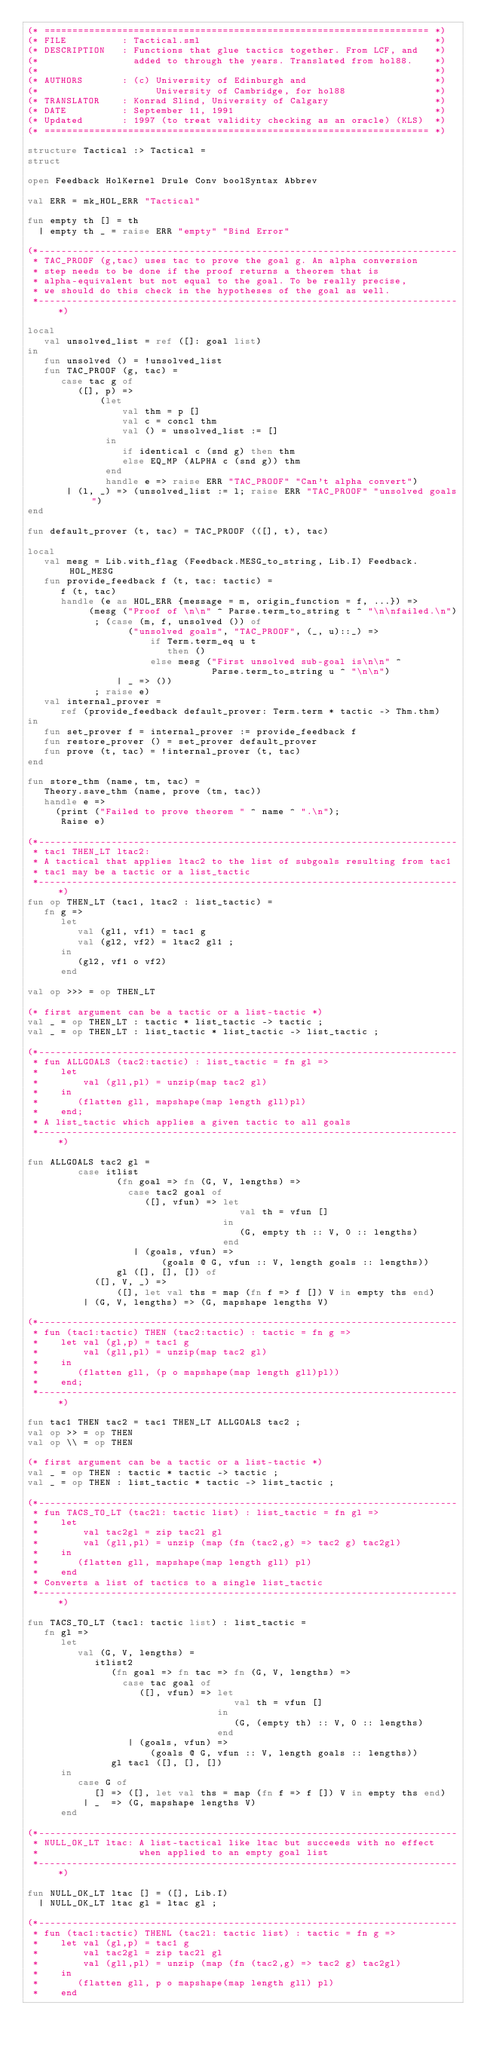Convert code to text. <code><loc_0><loc_0><loc_500><loc_500><_SML_>(* ===================================================================== *)
(* FILE          : Tactical.sml                                          *)
(* DESCRIPTION   : Functions that glue tactics together. From LCF, and   *)
(*                 added to through the years. Translated from hol88.    *)
(*                                                                       *)
(* AUTHORS       : (c) University of Edinburgh and                       *)
(*                     University of Cambridge, for hol88                *)
(* TRANSLATOR    : Konrad Slind, University of Calgary                   *)
(* DATE          : September 11, 1991                                    *)
(* Updated       : 1997 (to treat validity checking as an oracle) (KLS)  *)
(* ===================================================================== *)

structure Tactical :> Tactical =
struct

open Feedback HolKernel Drule Conv boolSyntax Abbrev

val ERR = mk_HOL_ERR "Tactical"

fun empty th [] = th
  | empty th _ = raise ERR "empty" "Bind Error"

(*---------------------------------------------------------------------------
 * TAC_PROOF (g,tac) uses tac to prove the goal g. An alpha conversion
 * step needs to be done if the proof returns a theorem that is
 * alpha-equivalent but not equal to the goal. To be really precise,
 * we should do this check in the hypotheses of the goal as well.
 *---------------------------------------------------------------------------*)

local
   val unsolved_list = ref ([]: goal list)
in
   fun unsolved () = !unsolved_list
   fun TAC_PROOF (g, tac) =
      case tac g of
         ([], p) =>
             (let
                 val thm = p []
                 val c = concl thm
                 val () = unsolved_list := []
              in
                 if identical c (snd g) then thm
                 else EQ_MP (ALPHA c (snd g)) thm
              end
              handle e => raise ERR "TAC_PROOF" "Can't alpha convert")
       | (l, _) => (unsolved_list := l; raise ERR "TAC_PROOF" "unsolved goals")
end

fun default_prover (t, tac) = TAC_PROOF (([], t), tac)

local
   val mesg = Lib.with_flag (Feedback.MESG_to_string, Lib.I) Feedback.HOL_MESG
   fun provide_feedback f (t, tac: tactic) =
      f (t, tac)
      handle (e as HOL_ERR {message = m, origin_function = f, ...}) =>
           (mesg ("Proof of \n\n" ^ Parse.term_to_string t ^ "\n\nfailed.\n")
            ; (case (m, f, unsolved ()) of
                  ("unsolved goals", "TAC_PROOF", (_, u)::_) =>
                      if Term.term_eq u t
                         then ()
                      else mesg ("First unsolved sub-goal is\n\n" ^
                                 Parse.term_to_string u ^ "\n\n")
                | _ => ())
            ; raise e)
   val internal_prover =
      ref (provide_feedback default_prover: Term.term * tactic -> Thm.thm)
in
   fun set_prover f = internal_prover := provide_feedback f
   fun restore_prover () = set_prover default_prover
   fun prove (t, tac) = !internal_prover (t, tac)
end

fun store_thm (name, tm, tac) =
   Theory.save_thm (name, prove (tm, tac))
   handle e =>
     (print ("Failed to prove theorem " ^ name ^ ".\n");
      Raise e)

(*---------------------------------------------------------------------------
 * tac1 THEN_LT ltac2:
 * A tactical that applies ltac2 to the list of subgoals resulting from tac1
 * tac1 may be a tactic or a list_tactic
 *---------------------------------------------------------------------------*)
fun op THEN_LT (tac1, ltac2 : list_tactic) =
   fn g =>
      let
         val (gl1, vf1) = tac1 g
         val (gl2, vf2) = ltac2 gl1 ;
      in
         (gl2, vf1 o vf2)
      end

val op >>> = op THEN_LT

(* first argument can be a tactic or a list-tactic *)
val _ = op THEN_LT : tactic * list_tactic -> tactic ;
val _ = op THEN_LT : list_tactic * list_tactic -> list_tactic ;

(*---------------------------------------------------------------------------
 * fun ALLGOALS (tac2:tactic) : list_tactic = fn gl =>
 *    let
 *        val (gll,pl) = unzip(map tac2 gl)
 *    in
 *       (flatten gll, mapshape(map length gll)pl)
 *    end;
 * A list_tactic which applies a given tactic to all goals
 *---------------------------------------------------------------------------*)

fun ALLGOALS tac2 gl =
         case itlist
                (fn goal => fn (G, V, lengths) =>
                  case tac2 goal of
                     ([], vfun) => let
                                      val th = vfun []
                                   in
                                      (G, empty th :: V, 0 :: lengths)
                                   end
                   | (goals, vfun) =>
                        (goals @ G, vfun :: V, length goals :: lengths))
                gl ([], [], []) of
            ([], V, _) =>
                ([], let val ths = map (fn f => f []) V in empty ths end)
          | (G, V, lengths) => (G, mapshape lengths V)

(*---------------------------------------------------------------------------
 * fun (tac1:tactic) THEN (tac2:tactic) : tactic = fn g =>
 *    let val (gl,p) = tac1 g
 *        val (gll,pl) = unzip(map tac2 gl)
 *    in
 *       (flatten gll, (p o mapshape(map length gll)pl))
 *    end;
 *---------------------------------------------------------------------------*)

fun tac1 THEN tac2 = tac1 THEN_LT ALLGOALS tac2 ;
val op >> = op THEN
val op \\ = op THEN

(* first argument can be a tactic or a list-tactic *)
val _ = op THEN : tactic * tactic -> tactic ;
val _ = op THEN : list_tactic * tactic -> list_tactic ;

(*---------------------------------------------------------------------------
 * fun TACS_TO_LT (tac2l: tactic list) : list_tactic = fn gl =>
 *    let
 *        val tac2gl = zip tac2l gl
 *        val (gll,pl) = unzip (map (fn (tac2,g) => tac2 g) tac2gl)
 *    in
 *       (flatten gll, mapshape(map length gll) pl)
 *    end
 * Converts a list of tactics to a single list_tactic
 *---------------------------------------------------------------------------*)

fun TACS_TO_LT (tacl: tactic list) : list_tactic =
   fn gl =>
      let
         val (G, V, lengths) =
            itlist2
               (fn goal => fn tac => fn (G, V, lengths) =>
                 case tac goal of
                    ([], vfun) => let
                                     val th = vfun []
                                  in
                                     (G, (empty th) :: V, 0 :: lengths)
                                  end
                  | (goals, vfun) =>
                      (goals @ G, vfun :: V, length goals :: lengths))
               gl tacl ([], [], [])
      in
         case G of
            [] => ([], let val ths = map (fn f => f []) V in empty ths end)
          | _  => (G, mapshape lengths V)
      end

(*---------------------------------------------------------------------------
 * NULL_OK_LT ltac: A list-tactical like ltac but succeeds with no effect
 *                  when applied to an empty goal list
 *---------------------------------------------------------------------------*)

fun NULL_OK_LT ltac [] = ([], Lib.I)
  | NULL_OK_LT ltac gl = ltac gl ;

(*---------------------------------------------------------------------------
 * fun (tac1:tactic) THENL (tac2l: tactic list) : tactic = fn g =>
 *    let val (gl,p) = tac1 g
 *        val tac2gl = zip tac2l gl
 *        val (gll,pl) = unzip (map (fn (tac2,g) => tac2 g) tac2gl)
 *    in
 *       (flatten gll, p o mapshape(map length gll) pl)
 *    end</code> 